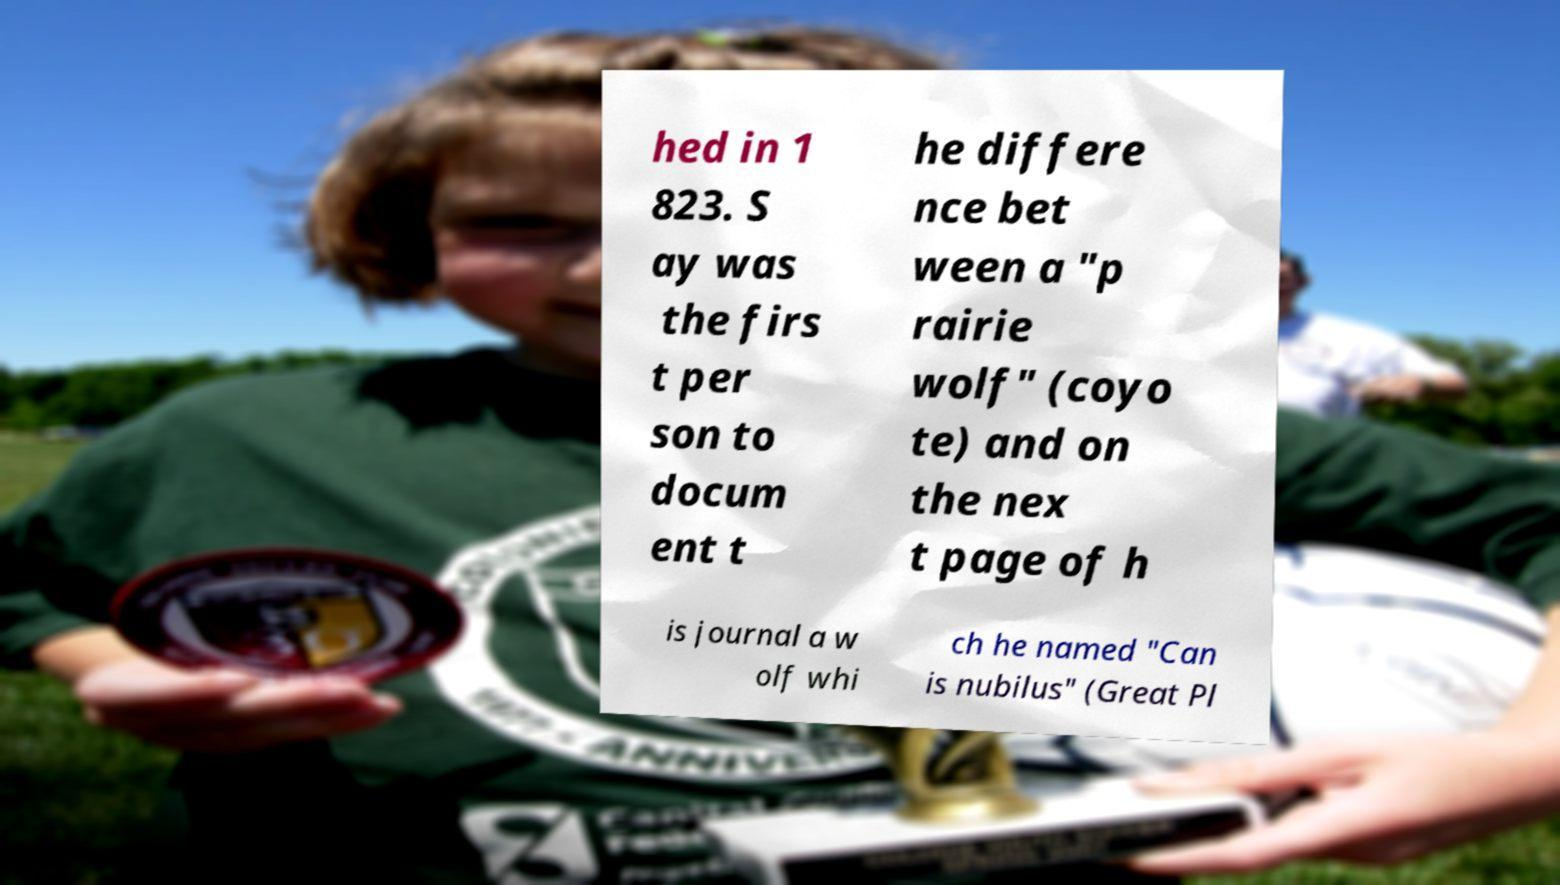What messages or text are displayed in this image? I need them in a readable, typed format. hed in 1 823. S ay was the firs t per son to docum ent t he differe nce bet ween a "p rairie wolf" (coyo te) and on the nex t page of h is journal a w olf whi ch he named "Can is nubilus" (Great Pl 